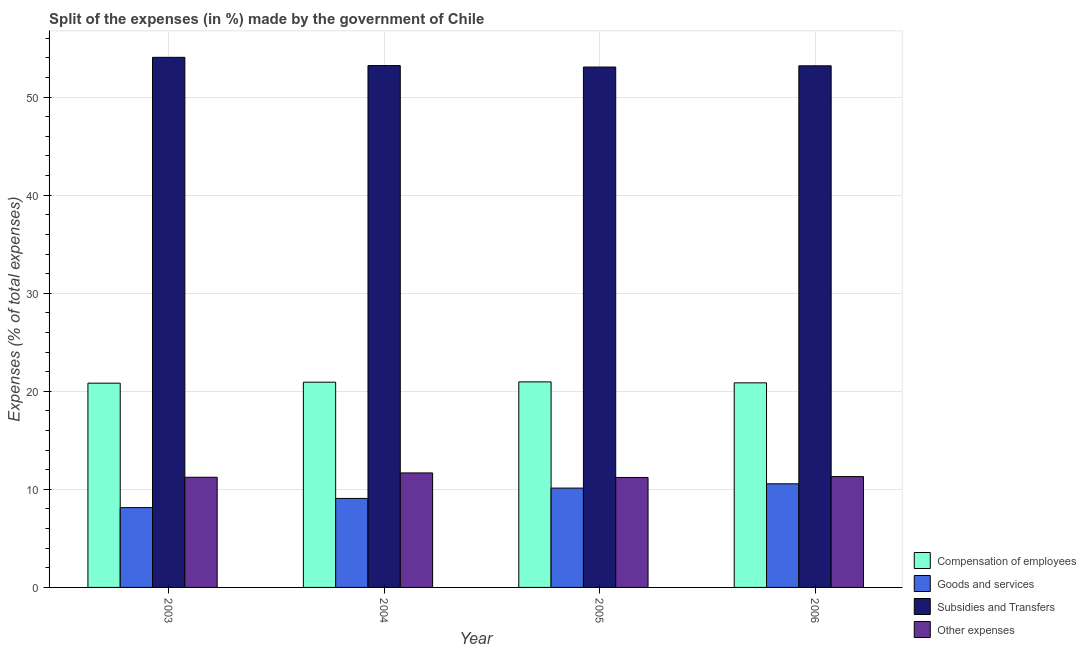How many different coloured bars are there?
Provide a succinct answer. 4. Are the number of bars on each tick of the X-axis equal?
Make the answer very short. Yes. How many bars are there on the 2nd tick from the right?
Provide a short and direct response. 4. What is the label of the 3rd group of bars from the left?
Provide a succinct answer. 2005. What is the percentage of amount spent on compensation of employees in 2005?
Offer a very short reply. 20.96. Across all years, what is the maximum percentage of amount spent on subsidies?
Provide a succinct answer. 54.06. Across all years, what is the minimum percentage of amount spent on compensation of employees?
Make the answer very short. 20.83. In which year was the percentage of amount spent on subsidies maximum?
Your answer should be very brief. 2003. What is the total percentage of amount spent on other expenses in the graph?
Your response must be concise. 45.42. What is the difference between the percentage of amount spent on goods and services in 2004 and that in 2005?
Keep it short and to the point. -1.05. What is the difference between the percentage of amount spent on other expenses in 2005 and the percentage of amount spent on goods and services in 2006?
Provide a succinct answer. -0.09. What is the average percentage of amount spent on subsidies per year?
Your response must be concise. 53.38. In how many years, is the percentage of amount spent on other expenses greater than 42 %?
Offer a very short reply. 0. What is the ratio of the percentage of amount spent on goods and services in 2003 to that in 2004?
Give a very brief answer. 0.9. Is the percentage of amount spent on compensation of employees in 2004 less than that in 2005?
Your response must be concise. Yes. What is the difference between the highest and the second highest percentage of amount spent on other expenses?
Keep it short and to the point. 0.38. What is the difference between the highest and the lowest percentage of amount spent on goods and services?
Offer a very short reply. 2.43. Is the sum of the percentage of amount spent on other expenses in 2003 and 2004 greater than the maximum percentage of amount spent on subsidies across all years?
Your answer should be very brief. Yes. What does the 3rd bar from the left in 2003 represents?
Your answer should be compact. Subsidies and Transfers. What does the 2nd bar from the right in 2003 represents?
Ensure brevity in your answer.  Subsidies and Transfers. Are all the bars in the graph horizontal?
Offer a terse response. No. What is the difference between two consecutive major ticks on the Y-axis?
Make the answer very short. 10. Are the values on the major ticks of Y-axis written in scientific E-notation?
Give a very brief answer. No. How are the legend labels stacked?
Your answer should be compact. Vertical. What is the title of the graph?
Offer a very short reply. Split of the expenses (in %) made by the government of Chile. Does "Energy" appear as one of the legend labels in the graph?
Your answer should be very brief. No. What is the label or title of the X-axis?
Your response must be concise. Year. What is the label or title of the Y-axis?
Your answer should be very brief. Expenses (% of total expenses). What is the Expenses (% of total expenses) in Compensation of employees in 2003?
Ensure brevity in your answer.  20.83. What is the Expenses (% of total expenses) of Goods and services in 2003?
Ensure brevity in your answer.  8.14. What is the Expenses (% of total expenses) of Subsidies and Transfers in 2003?
Offer a terse response. 54.06. What is the Expenses (% of total expenses) in Other expenses in 2003?
Your answer should be very brief. 11.23. What is the Expenses (% of total expenses) of Compensation of employees in 2004?
Keep it short and to the point. 20.93. What is the Expenses (% of total expenses) of Goods and services in 2004?
Ensure brevity in your answer.  9.08. What is the Expenses (% of total expenses) of Subsidies and Transfers in 2004?
Offer a terse response. 53.22. What is the Expenses (% of total expenses) in Other expenses in 2004?
Provide a succinct answer. 11.68. What is the Expenses (% of total expenses) in Compensation of employees in 2005?
Offer a terse response. 20.96. What is the Expenses (% of total expenses) of Goods and services in 2005?
Give a very brief answer. 10.13. What is the Expenses (% of total expenses) of Subsidies and Transfers in 2005?
Keep it short and to the point. 53.07. What is the Expenses (% of total expenses) of Other expenses in 2005?
Offer a very short reply. 11.21. What is the Expenses (% of total expenses) of Compensation of employees in 2006?
Offer a terse response. 20.86. What is the Expenses (% of total expenses) of Goods and services in 2006?
Offer a terse response. 10.57. What is the Expenses (% of total expenses) of Subsidies and Transfers in 2006?
Give a very brief answer. 53.19. What is the Expenses (% of total expenses) in Other expenses in 2006?
Your answer should be compact. 11.3. Across all years, what is the maximum Expenses (% of total expenses) in Compensation of employees?
Make the answer very short. 20.96. Across all years, what is the maximum Expenses (% of total expenses) in Goods and services?
Offer a very short reply. 10.57. Across all years, what is the maximum Expenses (% of total expenses) of Subsidies and Transfers?
Offer a very short reply. 54.06. Across all years, what is the maximum Expenses (% of total expenses) of Other expenses?
Your answer should be compact. 11.68. Across all years, what is the minimum Expenses (% of total expenses) of Compensation of employees?
Your answer should be very brief. 20.83. Across all years, what is the minimum Expenses (% of total expenses) of Goods and services?
Offer a terse response. 8.14. Across all years, what is the minimum Expenses (% of total expenses) of Subsidies and Transfers?
Your response must be concise. 53.07. Across all years, what is the minimum Expenses (% of total expenses) in Other expenses?
Ensure brevity in your answer.  11.21. What is the total Expenses (% of total expenses) in Compensation of employees in the graph?
Keep it short and to the point. 83.58. What is the total Expenses (% of total expenses) of Goods and services in the graph?
Give a very brief answer. 37.91. What is the total Expenses (% of total expenses) of Subsidies and Transfers in the graph?
Offer a terse response. 213.53. What is the total Expenses (% of total expenses) of Other expenses in the graph?
Give a very brief answer. 45.42. What is the difference between the Expenses (% of total expenses) of Compensation of employees in 2003 and that in 2004?
Provide a succinct answer. -0.1. What is the difference between the Expenses (% of total expenses) in Goods and services in 2003 and that in 2004?
Provide a succinct answer. -0.94. What is the difference between the Expenses (% of total expenses) in Subsidies and Transfers in 2003 and that in 2004?
Offer a very short reply. 0.84. What is the difference between the Expenses (% of total expenses) in Other expenses in 2003 and that in 2004?
Offer a very short reply. -0.44. What is the difference between the Expenses (% of total expenses) in Compensation of employees in 2003 and that in 2005?
Your response must be concise. -0.13. What is the difference between the Expenses (% of total expenses) in Goods and services in 2003 and that in 2005?
Provide a short and direct response. -1.99. What is the difference between the Expenses (% of total expenses) in Other expenses in 2003 and that in 2005?
Give a very brief answer. 0.02. What is the difference between the Expenses (% of total expenses) in Compensation of employees in 2003 and that in 2006?
Ensure brevity in your answer.  -0.03. What is the difference between the Expenses (% of total expenses) in Goods and services in 2003 and that in 2006?
Your response must be concise. -2.43. What is the difference between the Expenses (% of total expenses) of Subsidies and Transfers in 2003 and that in 2006?
Keep it short and to the point. 0.86. What is the difference between the Expenses (% of total expenses) of Other expenses in 2003 and that in 2006?
Ensure brevity in your answer.  -0.07. What is the difference between the Expenses (% of total expenses) of Compensation of employees in 2004 and that in 2005?
Your response must be concise. -0.03. What is the difference between the Expenses (% of total expenses) of Goods and services in 2004 and that in 2005?
Provide a succinct answer. -1.05. What is the difference between the Expenses (% of total expenses) of Subsidies and Transfers in 2004 and that in 2005?
Offer a terse response. 0.15. What is the difference between the Expenses (% of total expenses) of Other expenses in 2004 and that in 2005?
Give a very brief answer. 0.46. What is the difference between the Expenses (% of total expenses) in Compensation of employees in 2004 and that in 2006?
Make the answer very short. 0.07. What is the difference between the Expenses (% of total expenses) in Goods and services in 2004 and that in 2006?
Offer a very short reply. -1.49. What is the difference between the Expenses (% of total expenses) of Subsidies and Transfers in 2004 and that in 2006?
Give a very brief answer. 0.02. What is the difference between the Expenses (% of total expenses) of Other expenses in 2004 and that in 2006?
Your answer should be compact. 0.38. What is the difference between the Expenses (% of total expenses) in Compensation of employees in 2005 and that in 2006?
Your response must be concise. 0.1. What is the difference between the Expenses (% of total expenses) in Goods and services in 2005 and that in 2006?
Keep it short and to the point. -0.44. What is the difference between the Expenses (% of total expenses) of Subsidies and Transfers in 2005 and that in 2006?
Provide a short and direct response. -0.13. What is the difference between the Expenses (% of total expenses) of Other expenses in 2005 and that in 2006?
Your answer should be compact. -0.09. What is the difference between the Expenses (% of total expenses) in Compensation of employees in 2003 and the Expenses (% of total expenses) in Goods and services in 2004?
Offer a terse response. 11.75. What is the difference between the Expenses (% of total expenses) of Compensation of employees in 2003 and the Expenses (% of total expenses) of Subsidies and Transfers in 2004?
Your response must be concise. -32.39. What is the difference between the Expenses (% of total expenses) of Compensation of employees in 2003 and the Expenses (% of total expenses) of Other expenses in 2004?
Your answer should be very brief. 9.15. What is the difference between the Expenses (% of total expenses) of Goods and services in 2003 and the Expenses (% of total expenses) of Subsidies and Transfers in 2004?
Your answer should be very brief. -45.08. What is the difference between the Expenses (% of total expenses) in Goods and services in 2003 and the Expenses (% of total expenses) in Other expenses in 2004?
Offer a very short reply. -3.54. What is the difference between the Expenses (% of total expenses) in Subsidies and Transfers in 2003 and the Expenses (% of total expenses) in Other expenses in 2004?
Your answer should be compact. 42.38. What is the difference between the Expenses (% of total expenses) in Compensation of employees in 2003 and the Expenses (% of total expenses) in Goods and services in 2005?
Make the answer very short. 10.7. What is the difference between the Expenses (% of total expenses) in Compensation of employees in 2003 and the Expenses (% of total expenses) in Subsidies and Transfers in 2005?
Your answer should be very brief. -32.24. What is the difference between the Expenses (% of total expenses) of Compensation of employees in 2003 and the Expenses (% of total expenses) of Other expenses in 2005?
Keep it short and to the point. 9.62. What is the difference between the Expenses (% of total expenses) in Goods and services in 2003 and the Expenses (% of total expenses) in Subsidies and Transfers in 2005?
Offer a very short reply. -44.93. What is the difference between the Expenses (% of total expenses) of Goods and services in 2003 and the Expenses (% of total expenses) of Other expenses in 2005?
Ensure brevity in your answer.  -3.07. What is the difference between the Expenses (% of total expenses) of Subsidies and Transfers in 2003 and the Expenses (% of total expenses) of Other expenses in 2005?
Provide a succinct answer. 42.85. What is the difference between the Expenses (% of total expenses) in Compensation of employees in 2003 and the Expenses (% of total expenses) in Goods and services in 2006?
Your response must be concise. 10.26. What is the difference between the Expenses (% of total expenses) of Compensation of employees in 2003 and the Expenses (% of total expenses) of Subsidies and Transfers in 2006?
Your response must be concise. -32.36. What is the difference between the Expenses (% of total expenses) of Compensation of employees in 2003 and the Expenses (% of total expenses) of Other expenses in 2006?
Offer a terse response. 9.53. What is the difference between the Expenses (% of total expenses) in Goods and services in 2003 and the Expenses (% of total expenses) in Subsidies and Transfers in 2006?
Offer a terse response. -45.05. What is the difference between the Expenses (% of total expenses) of Goods and services in 2003 and the Expenses (% of total expenses) of Other expenses in 2006?
Make the answer very short. -3.16. What is the difference between the Expenses (% of total expenses) of Subsidies and Transfers in 2003 and the Expenses (% of total expenses) of Other expenses in 2006?
Your answer should be very brief. 42.76. What is the difference between the Expenses (% of total expenses) of Compensation of employees in 2004 and the Expenses (% of total expenses) of Goods and services in 2005?
Ensure brevity in your answer.  10.8. What is the difference between the Expenses (% of total expenses) of Compensation of employees in 2004 and the Expenses (% of total expenses) of Subsidies and Transfers in 2005?
Provide a short and direct response. -32.14. What is the difference between the Expenses (% of total expenses) in Compensation of employees in 2004 and the Expenses (% of total expenses) in Other expenses in 2005?
Give a very brief answer. 9.72. What is the difference between the Expenses (% of total expenses) in Goods and services in 2004 and the Expenses (% of total expenses) in Subsidies and Transfers in 2005?
Provide a short and direct response. -43.99. What is the difference between the Expenses (% of total expenses) in Goods and services in 2004 and the Expenses (% of total expenses) in Other expenses in 2005?
Keep it short and to the point. -2.14. What is the difference between the Expenses (% of total expenses) of Subsidies and Transfers in 2004 and the Expenses (% of total expenses) of Other expenses in 2005?
Keep it short and to the point. 42. What is the difference between the Expenses (% of total expenses) of Compensation of employees in 2004 and the Expenses (% of total expenses) of Goods and services in 2006?
Ensure brevity in your answer.  10.36. What is the difference between the Expenses (% of total expenses) in Compensation of employees in 2004 and the Expenses (% of total expenses) in Subsidies and Transfers in 2006?
Provide a short and direct response. -32.26. What is the difference between the Expenses (% of total expenses) in Compensation of employees in 2004 and the Expenses (% of total expenses) in Other expenses in 2006?
Your response must be concise. 9.63. What is the difference between the Expenses (% of total expenses) of Goods and services in 2004 and the Expenses (% of total expenses) of Subsidies and Transfers in 2006?
Provide a succinct answer. -44.12. What is the difference between the Expenses (% of total expenses) of Goods and services in 2004 and the Expenses (% of total expenses) of Other expenses in 2006?
Ensure brevity in your answer.  -2.22. What is the difference between the Expenses (% of total expenses) of Subsidies and Transfers in 2004 and the Expenses (% of total expenses) of Other expenses in 2006?
Your answer should be compact. 41.91. What is the difference between the Expenses (% of total expenses) of Compensation of employees in 2005 and the Expenses (% of total expenses) of Goods and services in 2006?
Give a very brief answer. 10.39. What is the difference between the Expenses (% of total expenses) of Compensation of employees in 2005 and the Expenses (% of total expenses) of Subsidies and Transfers in 2006?
Offer a terse response. -32.23. What is the difference between the Expenses (% of total expenses) of Compensation of employees in 2005 and the Expenses (% of total expenses) of Other expenses in 2006?
Keep it short and to the point. 9.66. What is the difference between the Expenses (% of total expenses) in Goods and services in 2005 and the Expenses (% of total expenses) in Subsidies and Transfers in 2006?
Your answer should be very brief. -43.06. What is the difference between the Expenses (% of total expenses) in Goods and services in 2005 and the Expenses (% of total expenses) in Other expenses in 2006?
Your answer should be compact. -1.17. What is the difference between the Expenses (% of total expenses) of Subsidies and Transfers in 2005 and the Expenses (% of total expenses) of Other expenses in 2006?
Provide a succinct answer. 41.77. What is the average Expenses (% of total expenses) of Compensation of employees per year?
Keep it short and to the point. 20.9. What is the average Expenses (% of total expenses) in Goods and services per year?
Offer a very short reply. 9.48. What is the average Expenses (% of total expenses) of Subsidies and Transfers per year?
Your response must be concise. 53.38. What is the average Expenses (% of total expenses) of Other expenses per year?
Offer a terse response. 11.36. In the year 2003, what is the difference between the Expenses (% of total expenses) of Compensation of employees and Expenses (% of total expenses) of Goods and services?
Provide a short and direct response. 12.69. In the year 2003, what is the difference between the Expenses (% of total expenses) in Compensation of employees and Expenses (% of total expenses) in Subsidies and Transfers?
Give a very brief answer. -33.23. In the year 2003, what is the difference between the Expenses (% of total expenses) of Compensation of employees and Expenses (% of total expenses) of Other expenses?
Your response must be concise. 9.6. In the year 2003, what is the difference between the Expenses (% of total expenses) in Goods and services and Expenses (% of total expenses) in Subsidies and Transfers?
Your answer should be very brief. -45.92. In the year 2003, what is the difference between the Expenses (% of total expenses) in Goods and services and Expenses (% of total expenses) in Other expenses?
Provide a short and direct response. -3.1. In the year 2003, what is the difference between the Expenses (% of total expenses) in Subsidies and Transfers and Expenses (% of total expenses) in Other expenses?
Keep it short and to the point. 42.82. In the year 2004, what is the difference between the Expenses (% of total expenses) in Compensation of employees and Expenses (% of total expenses) in Goods and services?
Make the answer very short. 11.85. In the year 2004, what is the difference between the Expenses (% of total expenses) in Compensation of employees and Expenses (% of total expenses) in Subsidies and Transfers?
Your answer should be very brief. -32.29. In the year 2004, what is the difference between the Expenses (% of total expenses) in Compensation of employees and Expenses (% of total expenses) in Other expenses?
Give a very brief answer. 9.25. In the year 2004, what is the difference between the Expenses (% of total expenses) in Goods and services and Expenses (% of total expenses) in Subsidies and Transfers?
Make the answer very short. -44.14. In the year 2004, what is the difference between the Expenses (% of total expenses) in Goods and services and Expenses (% of total expenses) in Other expenses?
Keep it short and to the point. -2.6. In the year 2004, what is the difference between the Expenses (% of total expenses) of Subsidies and Transfers and Expenses (% of total expenses) of Other expenses?
Ensure brevity in your answer.  41.54. In the year 2005, what is the difference between the Expenses (% of total expenses) of Compensation of employees and Expenses (% of total expenses) of Goods and services?
Provide a succinct answer. 10.83. In the year 2005, what is the difference between the Expenses (% of total expenses) in Compensation of employees and Expenses (% of total expenses) in Subsidies and Transfers?
Provide a short and direct response. -32.11. In the year 2005, what is the difference between the Expenses (% of total expenses) in Compensation of employees and Expenses (% of total expenses) in Other expenses?
Offer a very short reply. 9.75. In the year 2005, what is the difference between the Expenses (% of total expenses) of Goods and services and Expenses (% of total expenses) of Subsidies and Transfers?
Ensure brevity in your answer.  -42.94. In the year 2005, what is the difference between the Expenses (% of total expenses) in Goods and services and Expenses (% of total expenses) in Other expenses?
Make the answer very short. -1.08. In the year 2005, what is the difference between the Expenses (% of total expenses) in Subsidies and Transfers and Expenses (% of total expenses) in Other expenses?
Offer a terse response. 41.85. In the year 2006, what is the difference between the Expenses (% of total expenses) of Compensation of employees and Expenses (% of total expenses) of Goods and services?
Give a very brief answer. 10.3. In the year 2006, what is the difference between the Expenses (% of total expenses) of Compensation of employees and Expenses (% of total expenses) of Subsidies and Transfers?
Make the answer very short. -32.33. In the year 2006, what is the difference between the Expenses (% of total expenses) in Compensation of employees and Expenses (% of total expenses) in Other expenses?
Give a very brief answer. 9.56. In the year 2006, what is the difference between the Expenses (% of total expenses) in Goods and services and Expenses (% of total expenses) in Subsidies and Transfers?
Provide a short and direct response. -42.63. In the year 2006, what is the difference between the Expenses (% of total expenses) in Goods and services and Expenses (% of total expenses) in Other expenses?
Ensure brevity in your answer.  -0.73. In the year 2006, what is the difference between the Expenses (% of total expenses) in Subsidies and Transfers and Expenses (% of total expenses) in Other expenses?
Give a very brief answer. 41.89. What is the ratio of the Expenses (% of total expenses) of Goods and services in 2003 to that in 2004?
Your answer should be very brief. 0.9. What is the ratio of the Expenses (% of total expenses) of Subsidies and Transfers in 2003 to that in 2004?
Your answer should be very brief. 1.02. What is the ratio of the Expenses (% of total expenses) in Other expenses in 2003 to that in 2004?
Your answer should be very brief. 0.96. What is the ratio of the Expenses (% of total expenses) in Goods and services in 2003 to that in 2005?
Ensure brevity in your answer.  0.8. What is the ratio of the Expenses (% of total expenses) of Subsidies and Transfers in 2003 to that in 2005?
Provide a succinct answer. 1.02. What is the ratio of the Expenses (% of total expenses) in Compensation of employees in 2003 to that in 2006?
Ensure brevity in your answer.  1. What is the ratio of the Expenses (% of total expenses) of Goods and services in 2003 to that in 2006?
Provide a succinct answer. 0.77. What is the ratio of the Expenses (% of total expenses) of Subsidies and Transfers in 2003 to that in 2006?
Provide a short and direct response. 1.02. What is the ratio of the Expenses (% of total expenses) of Goods and services in 2004 to that in 2005?
Your answer should be very brief. 0.9. What is the ratio of the Expenses (% of total expenses) of Subsidies and Transfers in 2004 to that in 2005?
Provide a short and direct response. 1. What is the ratio of the Expenses (% of total expenses) of Other expenses in 2004 to that in 2005?
Your answer should be compact. 1.04. What is the ratio of the Expenses (% of total expenses) in Goods and services in 2004 to that in 2006?
Your response must be concise. 0.86. What is the ratio of the Expenses (% of total expenses) in Subsidies and Transfers in 2004 to that in 2006?
Ensure brevity in your answer.  1. What is the ratio of the Expenses (% of total expenses) in Other expenses in 2004 to that in 2006?
Make the answer very short. 1.03. What is the ratio of the Expenses (% of total expenses) of Goods and services in 2005 to that in 2006?
Your answer should be very brief. 0.96. What is the ratio of the Expenses (% of total expenses) of Subsidies and Transfers in 2005 to that in 2006?
Your answer should be compact. 1. What is the ratio of the Expenses (% of total expenses) in Other expenses in 2005 to that in 2006?
Your answer should be compact. 0.99. What is the difference between the highest and the second highest Expenses (% of total expenses) in Compensation of employees?
Your answer should be very brief. 0.03. What is the difference between the highest and the second highest Expenses (% of total expenses) in Goods and services?
Your response must be concise. 0.44. What is the difference between the highest and the second highest Expenses (% of total expenses) of Subsidies and Transfers?
Offer a terse response. 0.84. What is the difference between the highest and the second highest Expenses (% of total expenses) of Other expenses?
Offer a very short reply. 0.38. What is the difference between the highest and the lowest Expenses (% of total expenses) in Compensation of employees?
Your answer should be very brief. 0.13. What is the difference between the highest and the lowest Expenses (% of total expenses) in Goods and services?
Offer a terse response. 2.43. What is the difference between the highest and the lowest Expenses (% of total expenses) in Subsidies and Transfers?
Your answer should be very brief. 0.99. What is the difference between the highest and the lowest Expenses (% of total expenses) in Other expenses?
Offer a terse response. 0.46. 